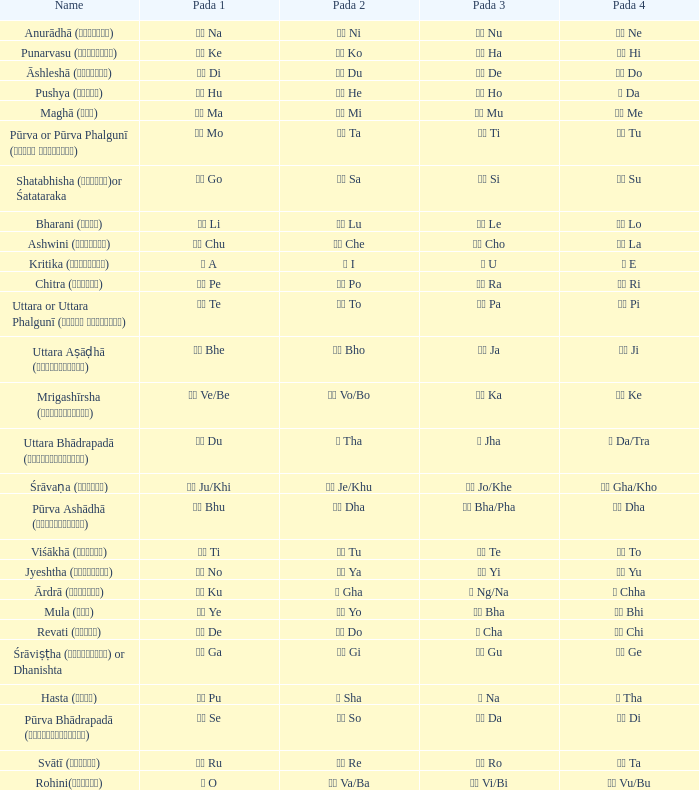What kind of Pada 1 has a Pada 2 of सा sa? गो Go. 